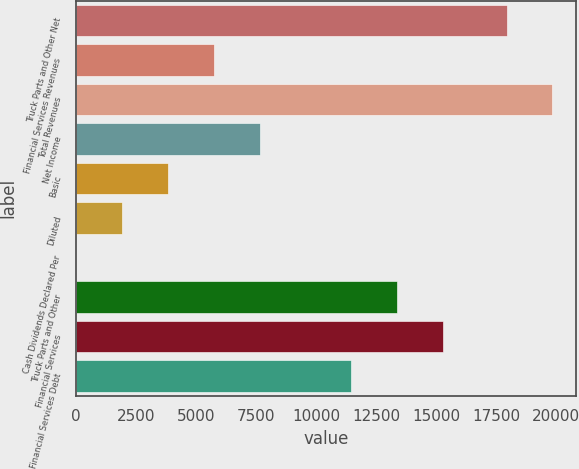Convert chart. <chart><loc_0><loc_0><loc_500><loc_500><bar_chart><fcel>Truck Parts and Other Net<fcel>Financial Services Revenues<fcel>Total Revenues<fcel>Net Income<fcel>Basic<fcel>Diluted<fcel>Cash Dividends Declared Per<fcel>Truck Parts and Other<fcel>Financial Services<fcel>Financial Services Debt<nl><fcel>17942.8<fcel>5736.16<fcel>19854.1<fcel>7647.44<fcel>3824.88<fcel>1913.6<fcel>2.32<fcel>13381.3<fcel>15292.6<fcel>11470<nl></chart> 